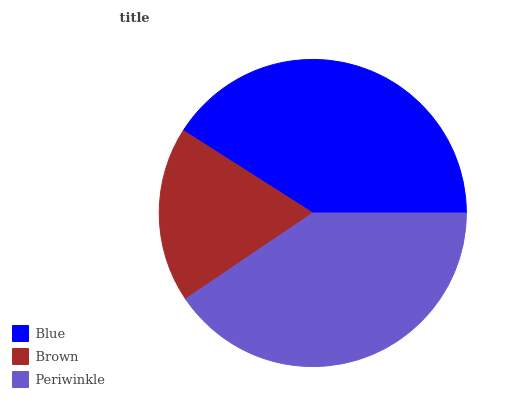Is Brown the minimum?
Answer yes or no. Yes. Is Blue the maximum?
Answer yes or no. Yes. Is Periwinkle the minimum?
Answer yes or no. No. Is Periwinkle the maximum?
Answer yes or no. No. Is Periwinkle greater than Brown?
Answer yes or no. Yes. Is Brown less than Periwinkle?
Answer yes or no. Yes. Is Brown greater than Periwinkle?
Answer yes or no. No. Is Periwinkle less than Brown?
Answer yes or no. No. Is Periwinkle the high median?
Answer yes or no. Yes. Is Periwinkle the low median?
Answer yes or no. Yes. Is Brown the high median?
Answer yes or no. No. Is Blue the low median?
Answer yes or no. No. 